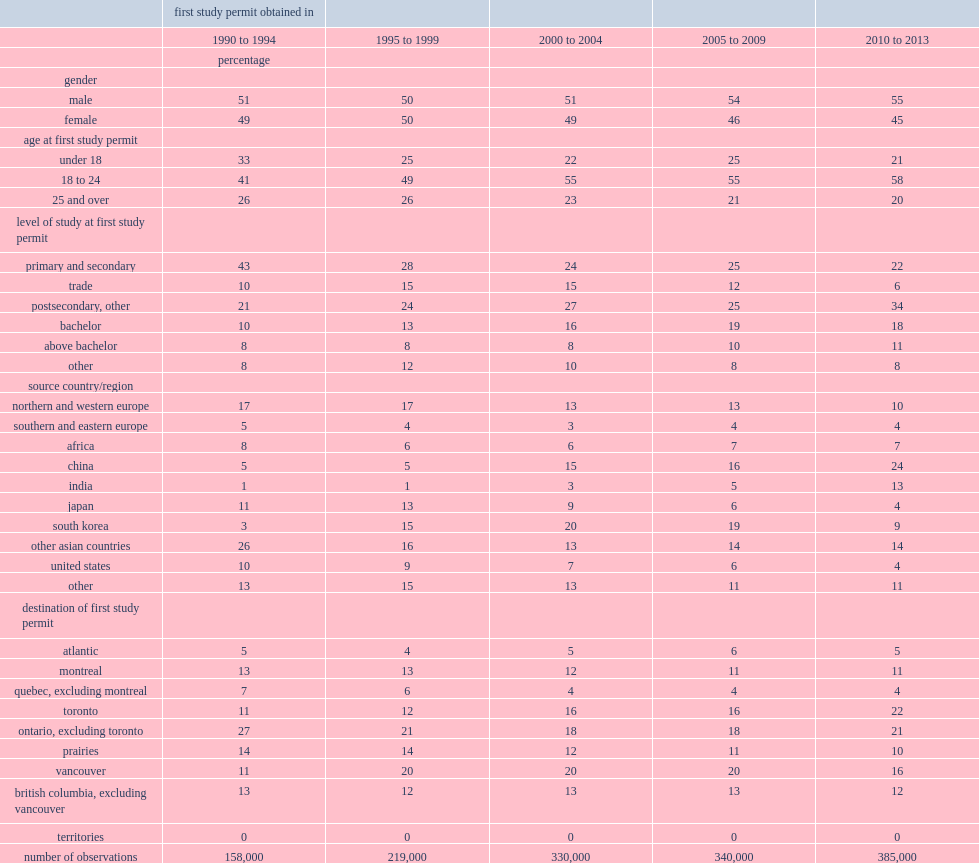Give me the full table as a dictionary. {'header': ['', 'first study permit obtained in', '', '', '', ''], 'rows': [['', '1990 to 1994', '1995 to 1999', '2000 to 2004', '2005 to 2009', '2010 to 2013'], ['', 'percentage', '', '', '', ''], ['gender', '', '', '', '', ''], ['male', '51', '50', '51', '54', '55'], ['female', '49', '50', '49', '46', '45'], ['age at first study permit', '', '', '', '', ''], ['under 18', '33', '25', '22', '25', '21'], ['18 to 24', '41', '49', '55', '55', '58'], ['25 and over', '26', '26', '23', '21', '20'], ['level of study at first study permit', '', '', '', '', ''], ['primary and secondary', '43', '28', '24', '25', '22'], ['trade', '10', '15', '15', '12', '6'], ['postsecondary, other', '21', '24', '27', '25', '34'], ['bachelor', '10', '13', '16', '19', '18'], ['above bachelor', '8', '8', '8', '10', '11'], ['other', '8', '12', '10', '8', '8'], ['source country/region', '', '', '', '', ''], ['northern and western europe', '17', '17', '13', '13', '10'], ['southern and eastern europe', '5', '4', '3', '4', '4'], ['africa', '8', '6', '6', '7', '7'], ['china', '5', '5', '15', '16', '24'], ['india', '1', '1', '3', '5', '13'], ['japan', '11', '13', '9', '6', '4'], ['south korea', '3', '15', '20', '19', '9'], ['other asian countries', '26', '16', '13', '14', '14'], ['united states', '10', '9', '7', '6', '4'], ['other', '13', '15', '13', '11', '11'], ['destination of first study permit', '', '', '', '', ''], ['atlantic', '5', '4', '5', '6', '5'], ['montreal', '13', '13', '12', '11', '11'], ['quebec, excluding montreal', '7', '6', '4', '4', '4'], ['toronto', '11', '12', '16', '16', '22'], ['ontario, excluding toronto', '27', '21', '18', '18', '21'], ['prairies', '14', '14', '12', '11', '10'], ['vancouver', '11', '20', '20', '20', '16'], ['british columbia, excluding vancouver', '13', '12', '13', '13', '12'], ['territories', '0', '0', '0', '0', '0'], ['number of observations', '158,000', '219,000', '330,000', '340,000', '385,000']]} Between 1990 and 1994,how many international students has canada received? 158000. Between 2005 and 2009,how many international students has canada received? 340000. Between 2010 and 2013,how many international students has canada received? 385000. Between 1990 and 1994,what is rates of international students are under the age of 25? 74. Between 2005 and 2009,what is rates of international students are under the age of 25? 80. In the early 1990s, what is the rate of international students came to canada to attend primary and secondary schools? 43.0. In the early 1990s, what is the rate of international students came to canada to pursue university education? 18. In the early 2010s, what is the rate of international students came to canada to pursue university education? 29. 